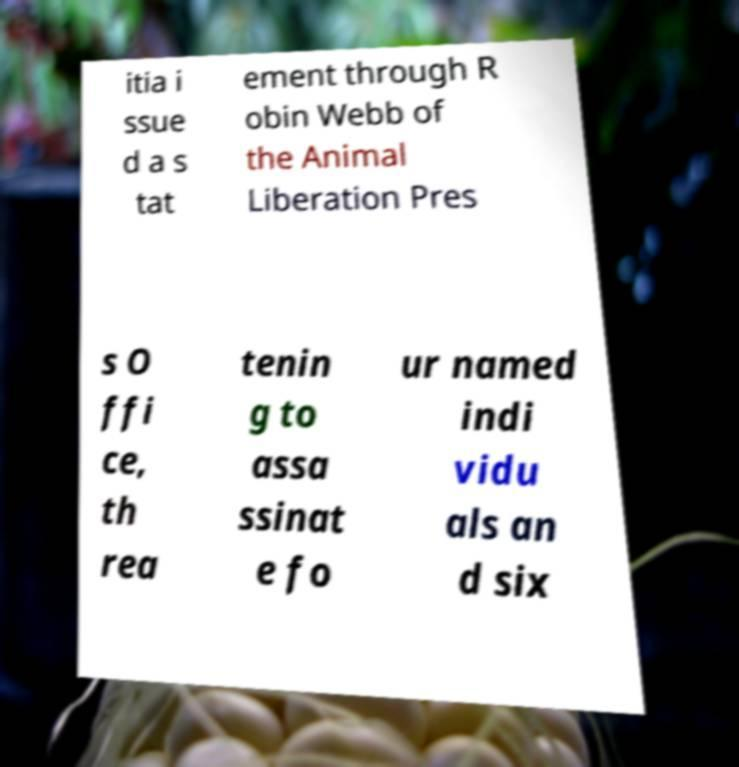There's text embedded in this image that I need extracted. Can you transcribe it verbatim? itia i ssue d a s tat ement through R obin Webb of the Animal Liberation Pres s O ffi ce, th rea tenin g to assa ssinat e fo ur named indi vidu als an d six 